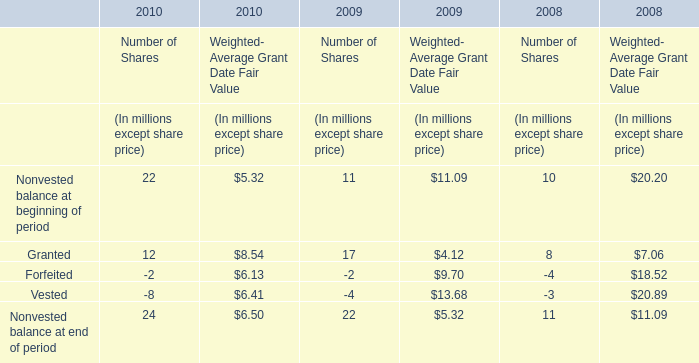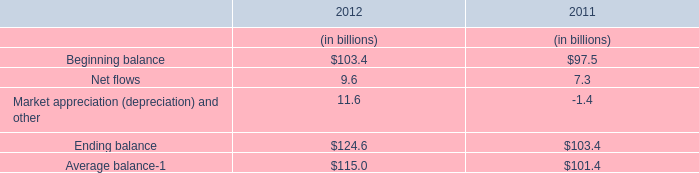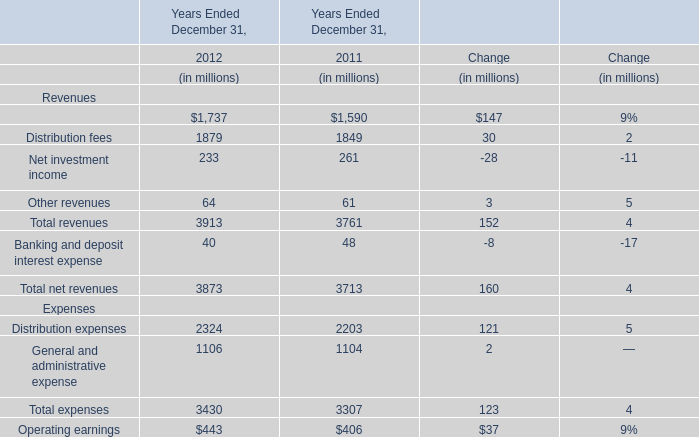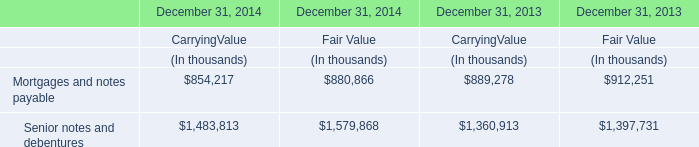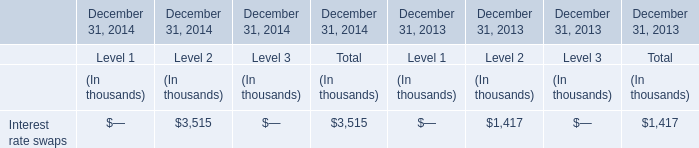What will distribution fees be like in 2013 if it continues to grow at the same rate as it did in 2012? (in million) 
Computations: ((((1879 - 1849) / 1849) + 1) * 1879)
Answer: 1909.48675. 